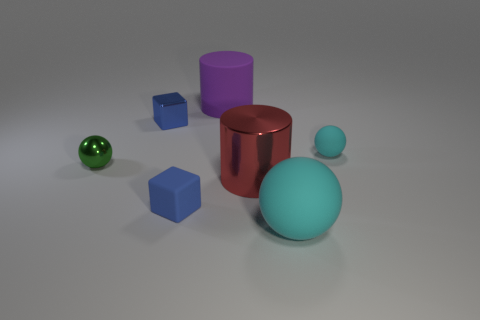Add 1 large cyan matte spheres. How many objects exist? 8 Subtract all spheres. How many objects are left? 4 Subtract all small blue shiny things. Subtract all small red cylinders. How many objects are left? 6 Add 6 big cylinders. How many big cylinders are left? 8 Add 5 blue rubber objects. How many blue rubber objects exist? 6 Subtract 1 cyan spheres. How many objects are left? 6 